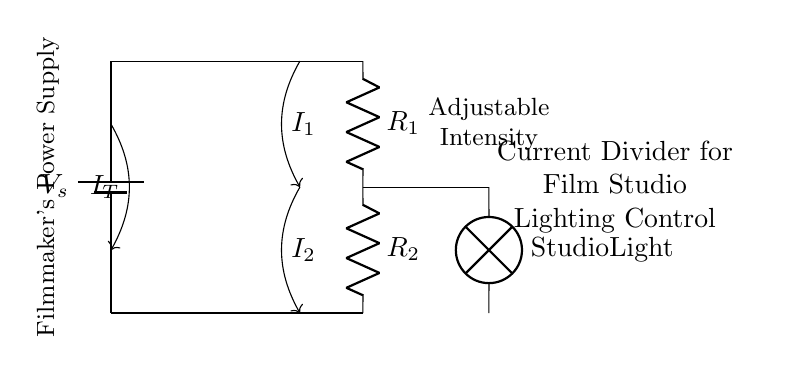What is the total current entering the circuit? The total current entering the circuit is denoted as IT. It's the current supplied from the power source to the combination of resistors R1 and R2.
Answer: IT What are the values of the resistors in the circuit? The resistors in this circuit are labeled R1 and R2. The actual numerical values aren’t provided in the diagram but typically you'd identify values based on the desired current division.
Answer: R1 and R2 How does the current divide between R1 and R2? The division of current depends on the resistance values of R1 and R2 according to the current divider rule. If R1 is larger, more current will flow through R2, and vice versa.
Answer: Based on resistance values What is the role of the lamp in this circuit? The lamp represents the studio light being powered and the current flowing through it adjusts its intensity based on the current received from the resistors.
Answer: Lighting intensity What effect does increasing R2 have on the lamp's brightness? Increasing R2 decreases the current through R2 (and thus through the lamp) as long as R1 stays constant, leading to a dimmer light.
Answer: Dims the light What type of circuit is illustrated here? This is a current divider circuit, which is specifically designed to split current into different branches at different intensities, perfect for controlling lighting in a studio.
Answer: Current divider circuit 